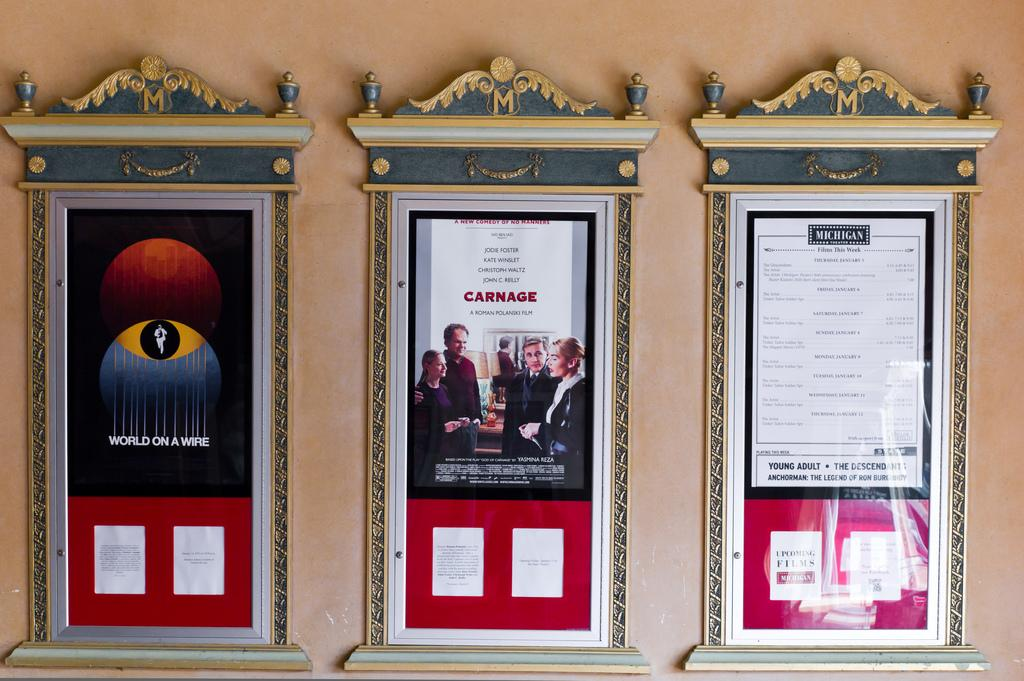What is attached to the wall in the image? There are boards on a wall in the image. How many oranges are placed inside the bucket in the image? There is no bucket or oranges present in the image; it only features boards on a wall. 